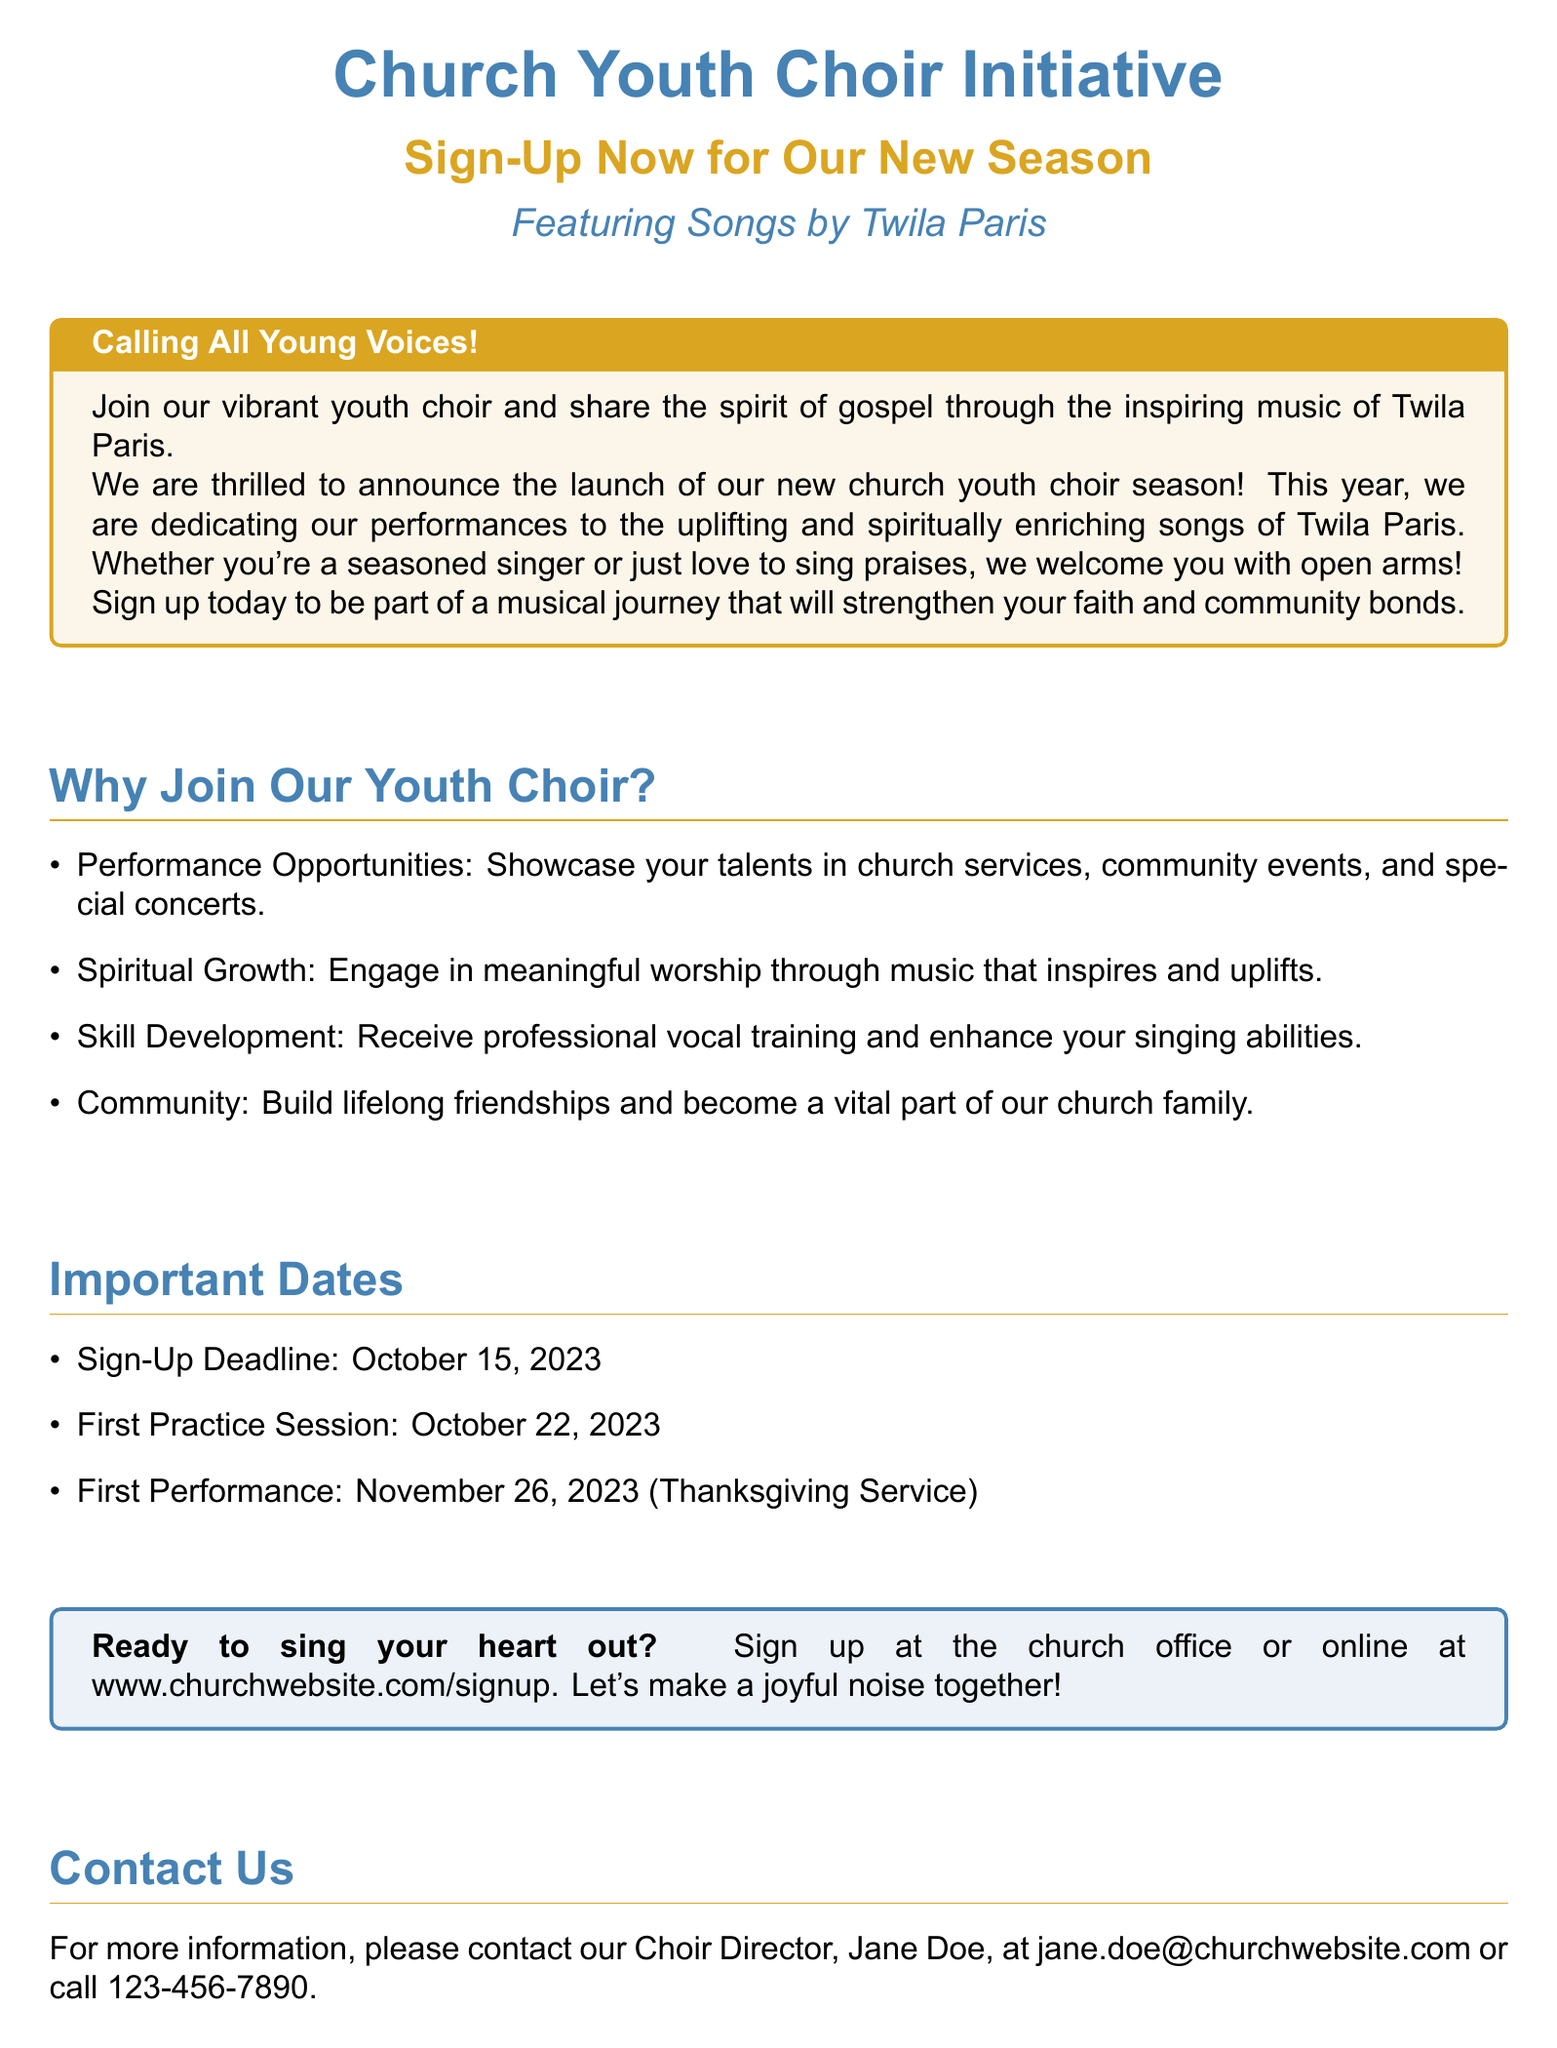What is the deadline for sign-up? The deadline for sign-up is specified in the Important Dates section of the document.
Answer: October 15, 2023 Who is the Choir Director? The document provides the name of the Choir Director in the Contact Us section.
Answer: Jane Doe When is the first practice session? The first practice session date is mentioned in the Important Dates section.
Answer: October 22, 2023 What type of music will the choir feature? The document explicitly states the type of music that will be featured by the choir.
Answer: Songs by Twila Paris What is the first performance date? The date of the first performance is outlined in the Important Dates section.
Answer: November 26, 2023 What are the benefits of joining the youth choir? The document lists several benefits under the Why Join Our Youth Choir? section, requiring a short summary of these advantages.
Answer: Performance Opportunities, Spiritual Growth, Skill Development, Community Where can you sign up? The document tells readers where to sign up in the final tcolorbox.
Answer: Church office or online at www.churchwebsite.com/signup What is the main purpose of this initiative? The flyer states the initiative’s purpose in the introductory sentences.
Answer: To share the spirit of gospel through music 